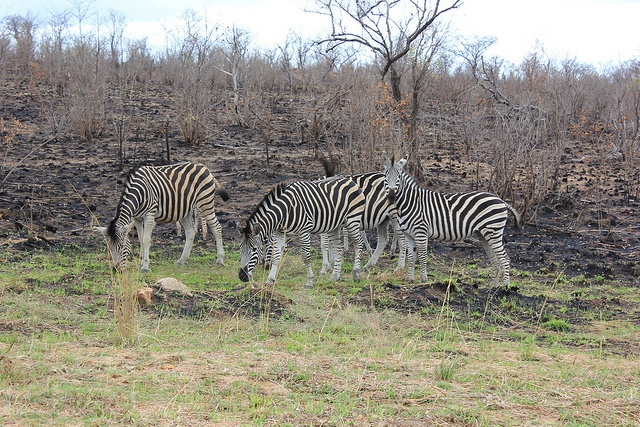Describe the objects in this image and their specific colors. I can see zebra in white, black, gray, darkgray, and lightgray tones, zebra in white, darkgray, black, and gray tones, zebra in white, black, darkgray, gray, and lightgray tones, and zebra in white, darkgray, black, gray, and lightgray tones in this image. 